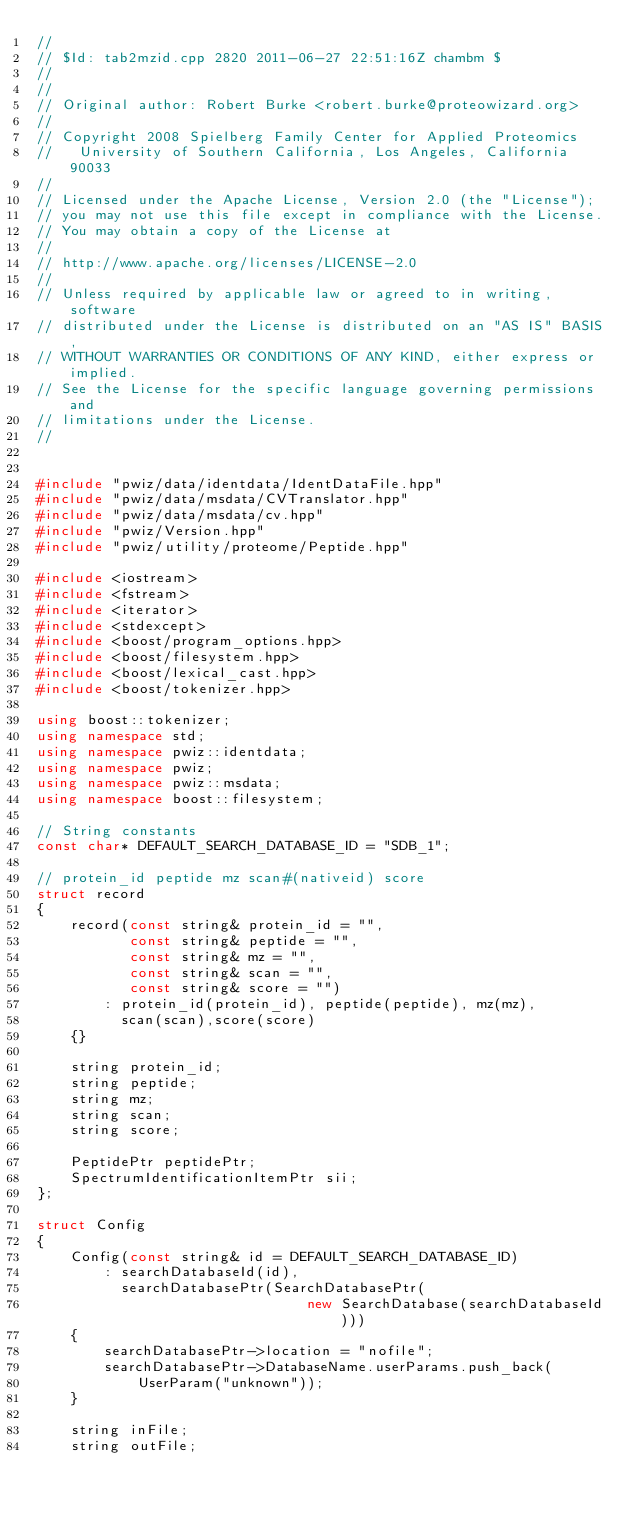<code> <loc_0><loc_0><loc_500><loc_500><_C++_>//
// $Id: tab2mzid.cpp 2820 2011-06-27 22:51:16Z chambm $
//
//
// Original author: Robert Burke <robert.burke@proteowizard.org>
//
// Copyright 2008 Spielberg Family Center for Applied Proteomics
//   University of Southern California, Los Angeles, California  90033
//
// Licensed under the Apache License, Version 2.0 (the "License"); 
// you may not use this file except in compliance with the License. 
// You may obtain a copy of the License at 
//
// http://www.apache.org/licenses/LICENSE-2.0
//
// Unless required by applicable law or agreed to in writing, software 
// distributed under the License is distributed on an "AS IS" BASIS, 
// WITHOUT WARRANTIES OR CONDITIONS OF ANY KIND, either express or implied. 
// See the License for the specific language governing permissions and 
// limitations under the License.
//


#include "pwiz/data/identdata/IdentDataFile.hpp"
#include "pwiz/data/msdata/CVTranslator.hpp"
#include "pwiz/data/msdata/cv.hpp"
#include "pwiz/Version.hpp"
#include "pwiz/utility/proteome/Peptide.hpp"

#include <iostream>
#include <fstream>
#include <iterator>
#include <stdexcept>
#include <boost/program_options.hpp>
#include <boost/filesystem.hpp>
#include <boost/lexical_cast.hpp>
#include <boost/tokenizer.hpp>

using boost::tokenizer;
using namespace std;
using namespace pwiz::identdata;
using namespace pwiz;
using namespace pwiz::msdata;
using namespace boost::filesystem;

// String constants
const char* DEFAULT_SEARCH_DATABASE_ID = "SDB_1";

// protein_id peptide mz scan#(nativeid) score
struct record
{
    record(const string& protein_id = "",
           const string& peptide = "",
           const string& mz = "",
           const string& scan = "",
           const string& score = "")
        : protein_id(protein_id), peptide(peptide), mz(mz),
          scan(scan),score(score)
    {}

    string protein_id;
    string peptide;
    string mz;
    string scan;
    string score;

    PeptidePtr peptidePtr;
    SpectrumIdentificationItemPtr sii;
};

struct Config
{
    Config(const string& id = DEFAULT_SEARCH_DATABASE_ID)
        : searchDatabaseId(id),
          searchDatabasePtr(SearchDatabasePtr(
                                new SearchDatabase(searchDatabaseId)))
    {
        searchDatabasePtr->location = "nofile";
        searchDatabasePtr->DatabaseName.userParams.push_back(
            UserParam("unknown"));
    }
    
    string inFile;
    string outFile;</code> 